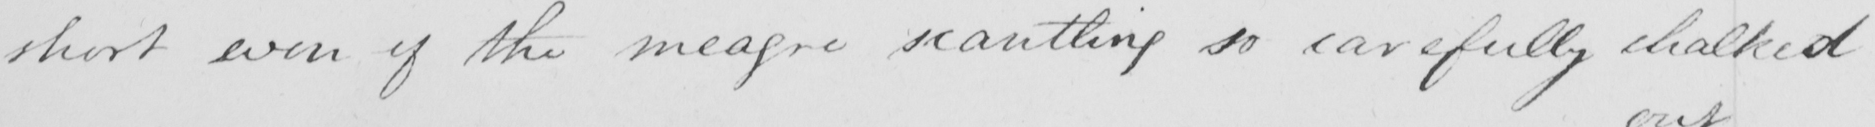What is written in this line of handwriting? short even if the meagre scantling so carefully chalked 